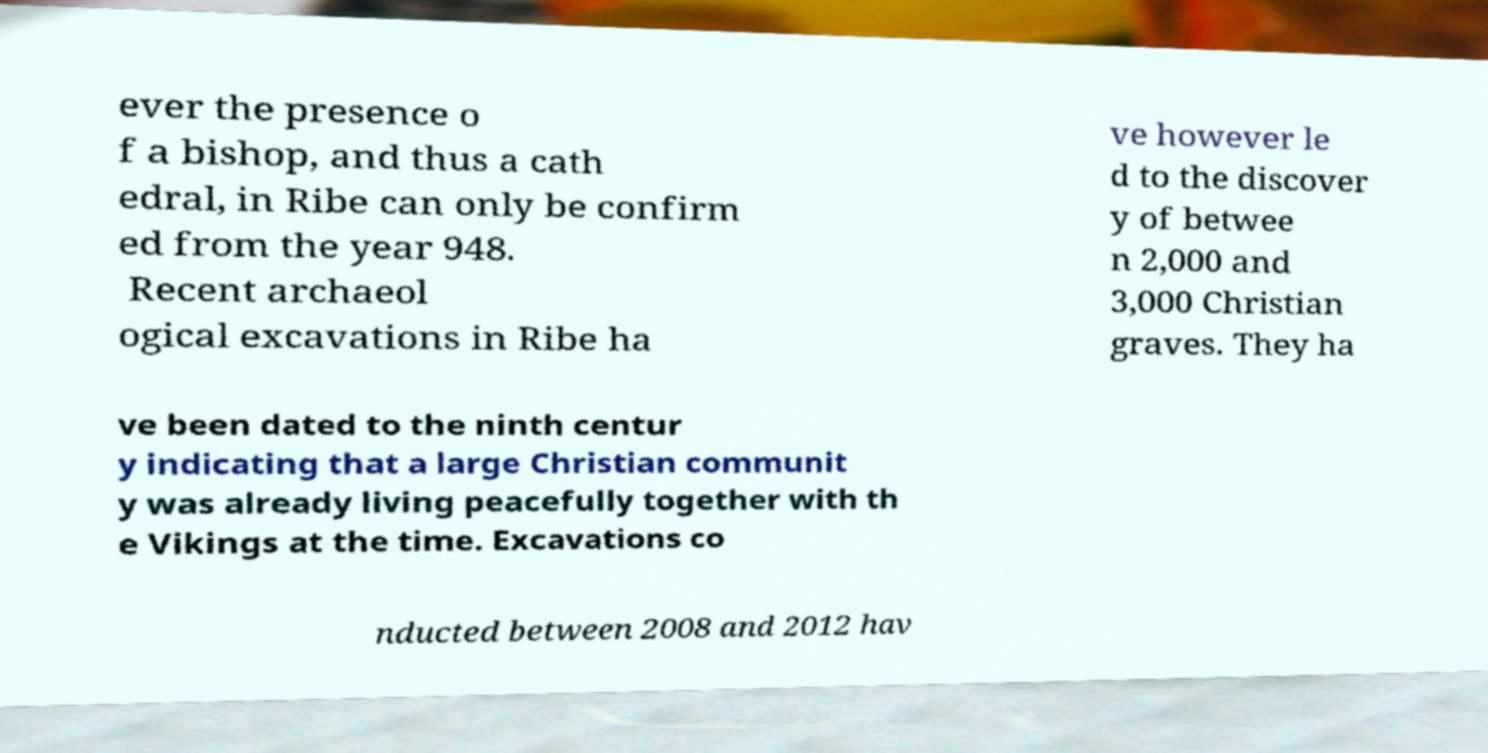Could you extract and type out the text from this image? ever the presence o f a bishop, and thus a cath edral, in Ribe can only be confirm ed from the year 948. Recent archaeol ogical excavations in Ribe ha ve however le d to the discover y of betwee n 2,000 and 3,000 Christian graves. They ha ve been dated to the ninth centur y indicating that a large Christian communit y was already living peacefully together with th e Vikings at the time. Excavations co nducted between 2008 and 2012 hav 